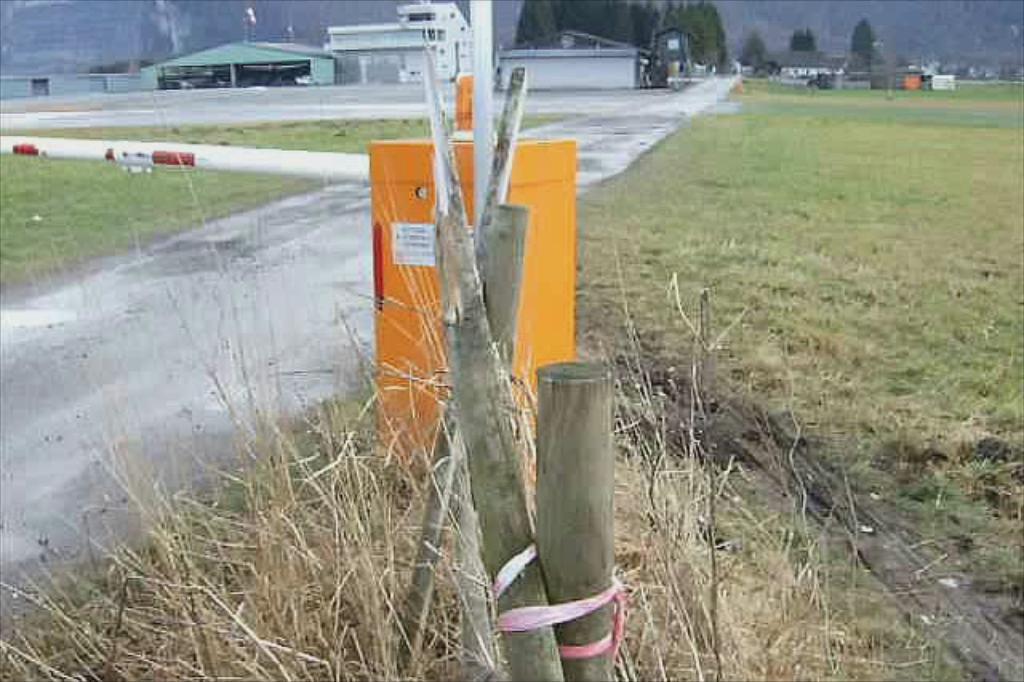Could you give a brief overview of what you see in this image? This image consists of wooden sticks and green grass on the ground. On the left, there is a road. In the background, there are buildings and trees. 